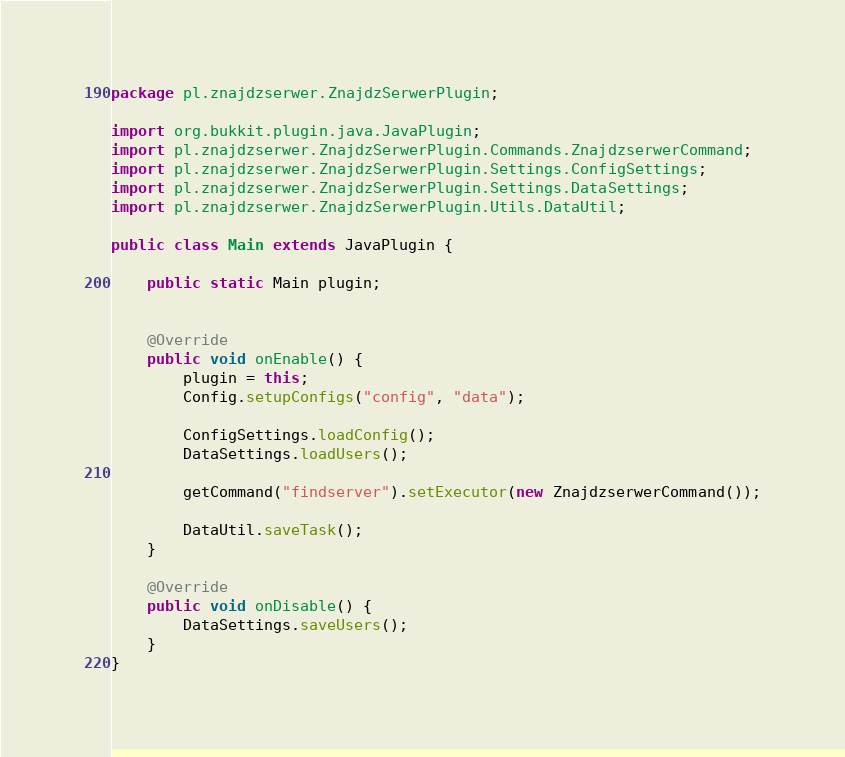<code> <loc_0><loc_0><loc_500><loc_500><_Java_>package pl.znajdzserwer.ZnajdzSerwerPlugin;

import org.bukkit.plugin.java.JavaPlugin;
import pl.znajdzserwer.ZnajdzSerwerPlugin.Commands.ZnajdzserwerCommand;
import pl.znajdzserwer.ZnajdzSerwerPlugin.Settings.ConfigSettings;
import pl.znajdzserwer.ZnajdzSerwerPlugin.Settings.DataSettings;
import pl.znajdzserwer.ZnajdzSerwerPlugin.Utils.DataUtil;

public class Main extends JavaPlugin {

    public static Main plugin;
    

    @Override
    public void onEnable() {
        plugin = this;
        Config.setupConfigs("config", "data");

        ConfigSettings.loadConfig();
        DataSettings.loadUsers();

        getCommand("findserver").setExecutor(new ZnajdzserwerCommand());

        DataUtil.saveTask();
    }

    @Override
    public void onDisable() {
        DataSettings.saveUsers();
    }
}
</code> 